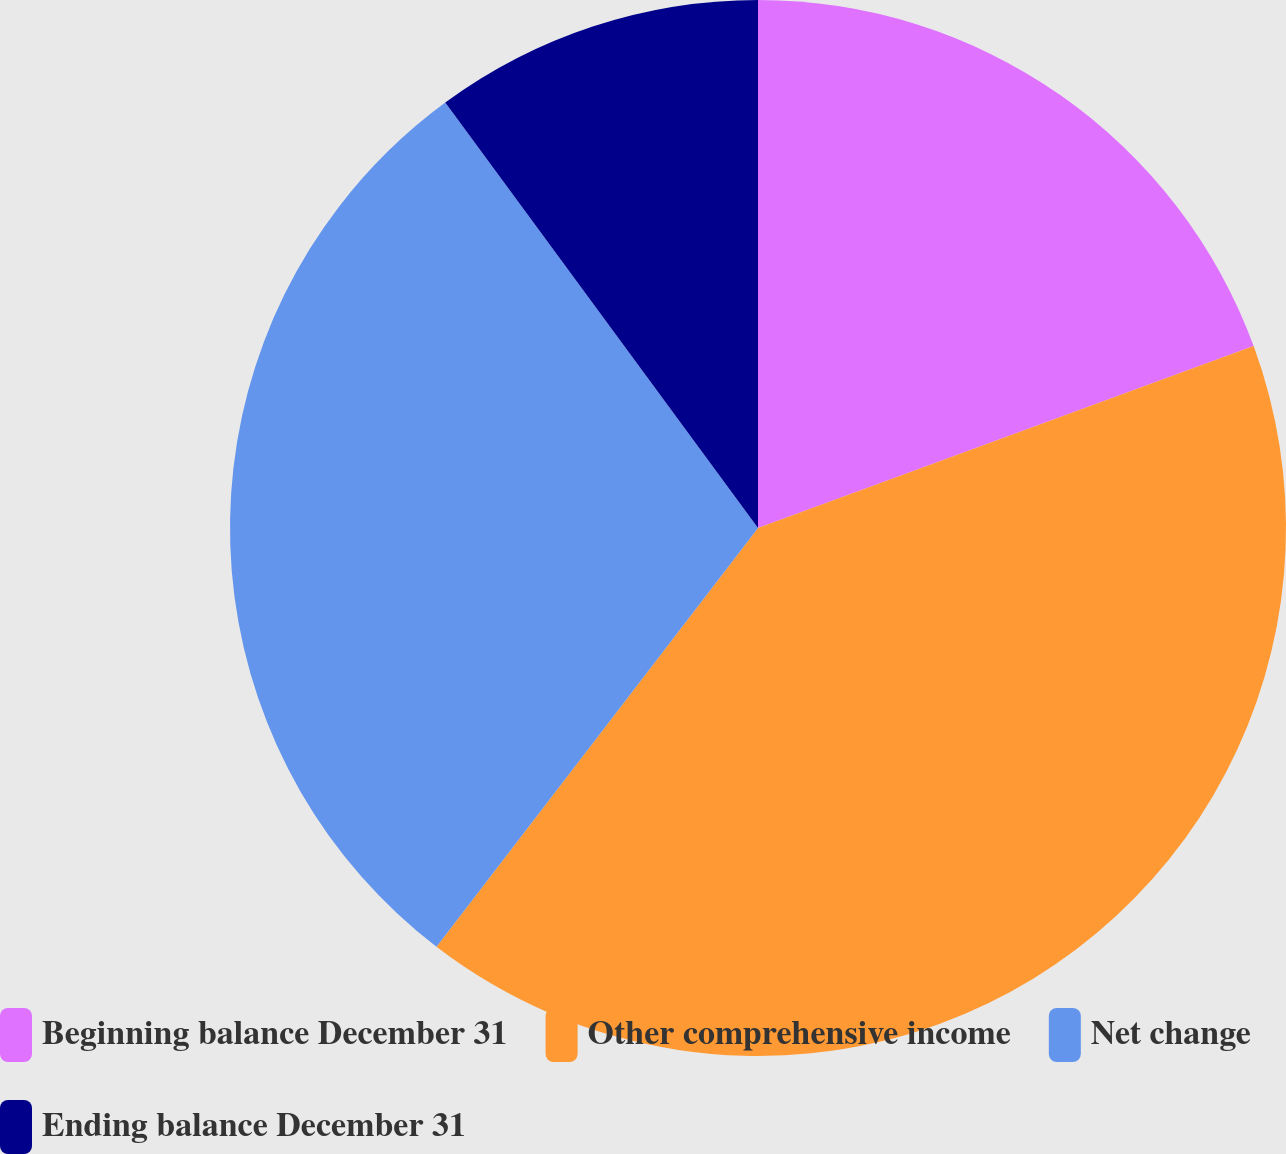<chart> <loc_0><loc_0><loc_500><loc_500><pie_chart><fcel>Beginning balance December 31<fcel>Other comprehensive income<fcel>Net change<fcel>Ending balance December 31<nl><fcel>19.4%<fcel>41.02%<fcel>29.49%<fcel>10.09%<nl></chart> 